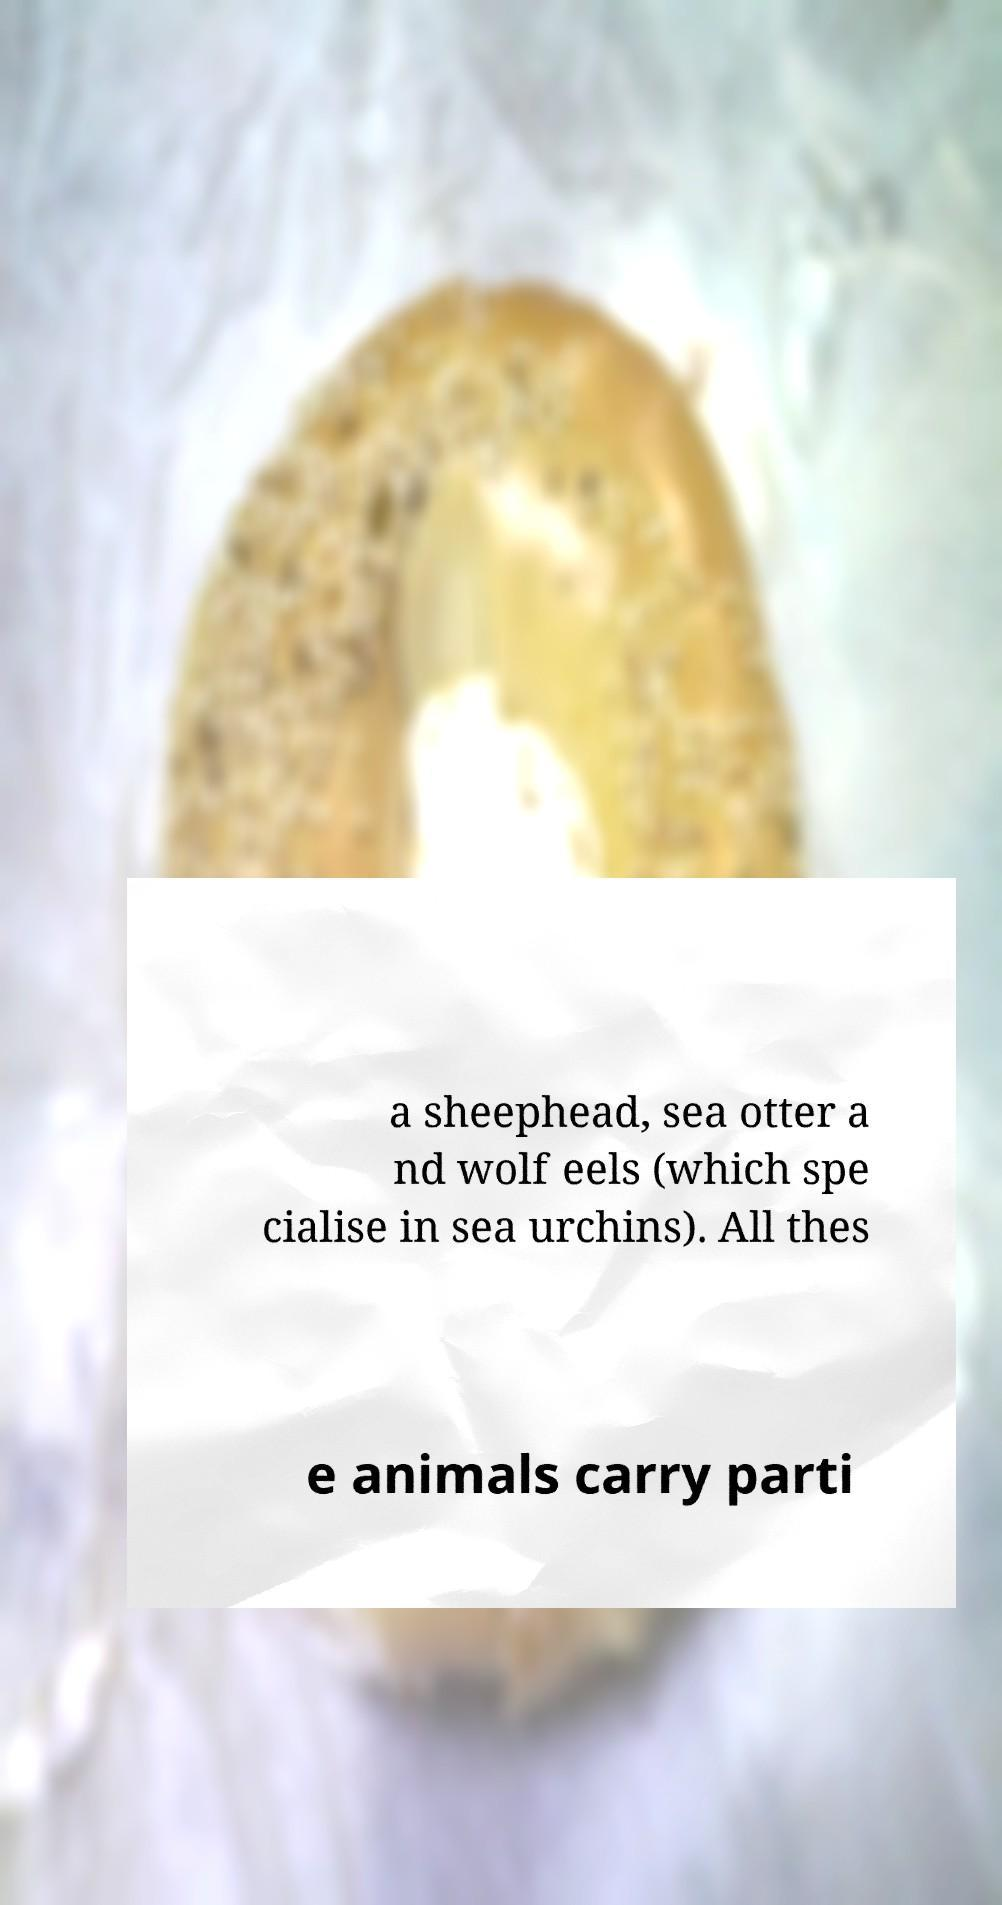For documentation purposes, I need the text within this image transcribed. Could you provide that? a sheephead, sea otter a nd wolf eels (which spe cialise in sea urchins). All thes e animals carry parti 